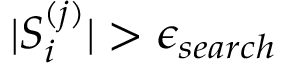Convert formula to latex. <formula><loc_0><loc_0><loc_500><loc_500>| S _ { i } ^ { ( j ) } | > \epsilon _ { s e a r c h }</formula> 